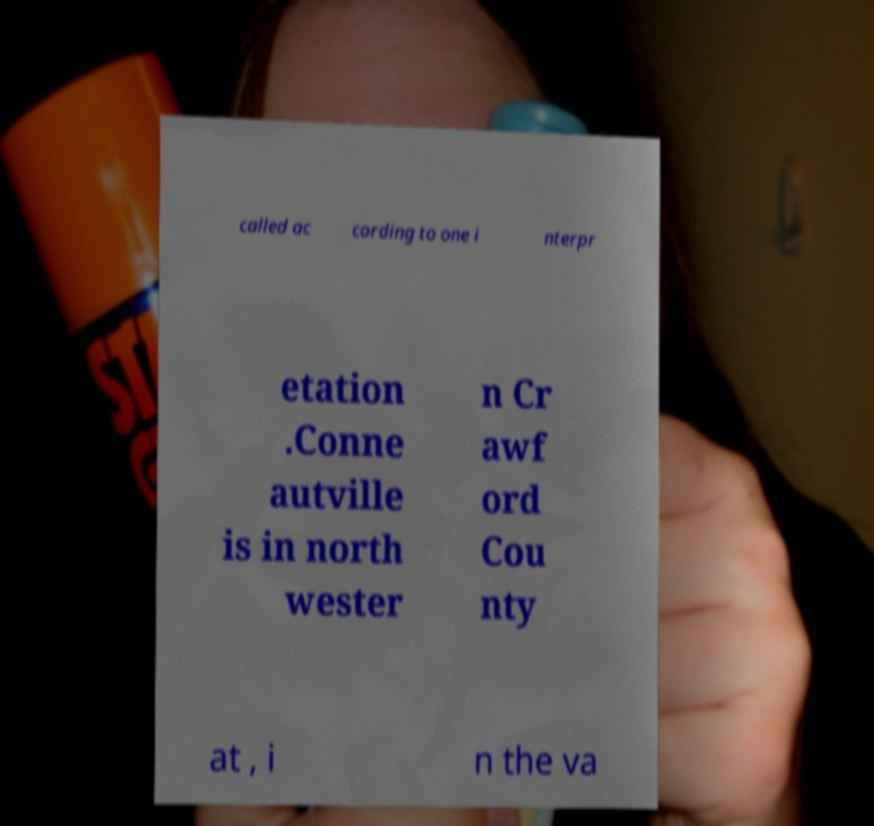I need the written content from this picture converted into text. Can you do that? called ac cording to one i nterpr etation .Conne autville is in north wester n Cr awf ord Cou nty at , i n the va 